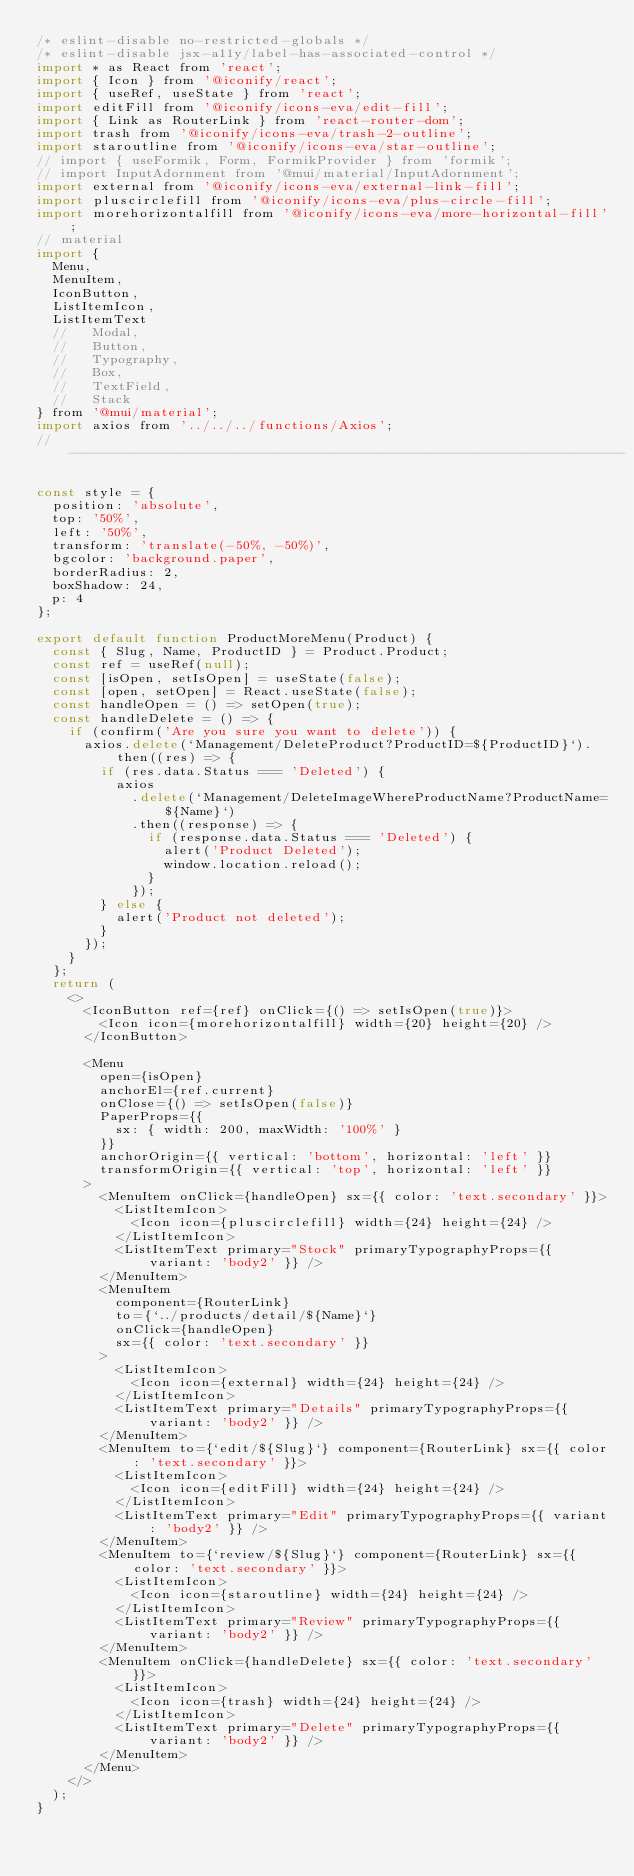Convert code to text. <code><loc_0><loc_0><loc_500><loc_500><_JavaScript_>/* eslint-disable no-restricted-globals */
/* eslint-disable jsx-a11y/label-has-associated-control */
import * as React from 'react';
import { Icon } from '@iconify/react';
import { useRef, useState } from 'react';
import editFill from '@iconify/icons-eva/edit-fill';
import { Link as RouterLink } from 'react-router-dom';
import trash from '@iconify/icons-eva/trash-2-outline';
import staroutline from '@iconify/icons-eva/star-outline';
// import { useFormik, Form, FormikProvider } from 'formik';
// import InputAdornment from '@mui/material/InputAdornment';
import external from '@iconify/icons-eva/external-link-fill';
import pluscirclefill from '@iconify/icons-eva/plus-circle-fill';
import morehorizontalfill from '@iconify/icons-eva/more-horizontal-fill';
// material
import {
  Menu,
  MenuItem,
  IconButton,
  ListItemIcon,
  ListItemText
  //   Modal,
  //   Button,
  //   Typography,
  //   Box,
  //   TextField,
  //   Stack
} from '@mui/material';
import axios from '../../../functions/Axios';
// ----------------------------------------------------------------------

const style = {
  position: 'absolute',
  top: '50%',
  left: '50%',
  transform: 'translate(-50%, -50%)',
  bgcolor: 'background.paper',
  borderRadius: 2,
  boxShadow: 24,
  p: 4
};

export default function ProductMoreMenu(Product) {
  const { Slug, Name, ProductID } = Product.Product;
  const ref = useRef(null);
  const [isOpen, setIsOpen] = useState(false);
  const [open, setOpen] = React.useState(false);
  const handleOpen = () => setOpen(true);
  const handleDelete = () => {
    if (confirm('Are you sure you want to delete')) {
      axios.delete(`Management/DeleteProduct?ProductID=${ProductID}`).then((res) => {
        if (res.data.Status === 'Deleted') {
          axios
            .delete(`Management/DeleteImageWhereProductName?ProductName=${Name}`)
            .then((response) => {
              if (response.data.Status === 'Deleted') {
                alert('Product Deleted');
                window.location.reload();
              }
            });
        } else {
          alert('Product not deleted');
        }
      });
    }
  };
  return (
    <>
      <IconButton ref={ref} onClick={() => setIsOpen(true)}>
        <Icon icon={morehorizontalfill} width={20} height={20} />
      </IconButton>

      <Menu
        open={isOpen}
        anchorEl={ref.current}
        onClose={() => setIsOpen(false)}
        PaperProps={{
          sx: { width: 200, maxWidth: '100%' }
        }}
        anchorOrigin={{ vertical: 'bottom', horizontal: 'left' }}
        transformOrigin={{ vertical: 'top', horizontal: 'left' }}
      >
        <MenuItem onClick={handleOpen} sx={{ color: 'text.secondary' }}>
          <ListItemIcon>
            <Icon icon={pluscirclefill} width={24} height={24} />
          </ListItemIcon>
          <ListItemText primary="Stock" primaryTypographyProps={{ variant: 'body2' }} />
        </MenuItem>
        <MenuItem
          component={RouterLink}
          to={`../products/detail/${Name}`}
          onClick={handleOpen}
          sx={{ color: 'text.secondary' }}
        >
          <ListItemIcon>
            <Icon icon={external} width={24} height={24} />
          </ListItemIcon>
          <ListItemText primary="Details" primaryTypographyProps={{ variant: 'body2' }} />
        </MenuItem>
        <MenuItem to={`edit/${Slug}`} component={RouterLink} sx={{ color: 'text.secondary' }}>
          <ListItemIcon>
            <Icon icon={editFill} width={24} height={24} />
          </ListItemIcon>
          <ListItemText primary="Edit" primaryTypographyProps={{ variant: 'body2' }} />
        </MenuItem>
        <MenuItem to={`review/${Slug}`} component={RouterLink} sx={{ color: 'text.secondary' }}>
          <ListItemIcon>
            <Icon icon={staroutline} width={24} height={24} />
          </ListItemIcon>
          <ListItemText primary="Review" primaryTypographyProps={{ variant: 'body2' }} />
        </MenuItem>
        <MenuItem onClick={handleDelete} sx={{ color: 'text.secondary' }}>
          <ListItemIcon>
            <Icon icon={trash} width={24} height={24} />
          </ListItemIcon>
          <ListItemText primary="Delete" primaryTypographyProps={{ variant: 'body2' }} />
        </MenuItem>
      </Menu>
    </>
  );
}
</code> 